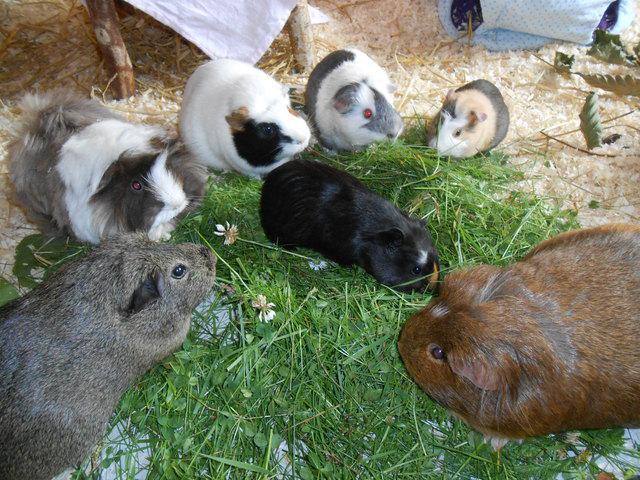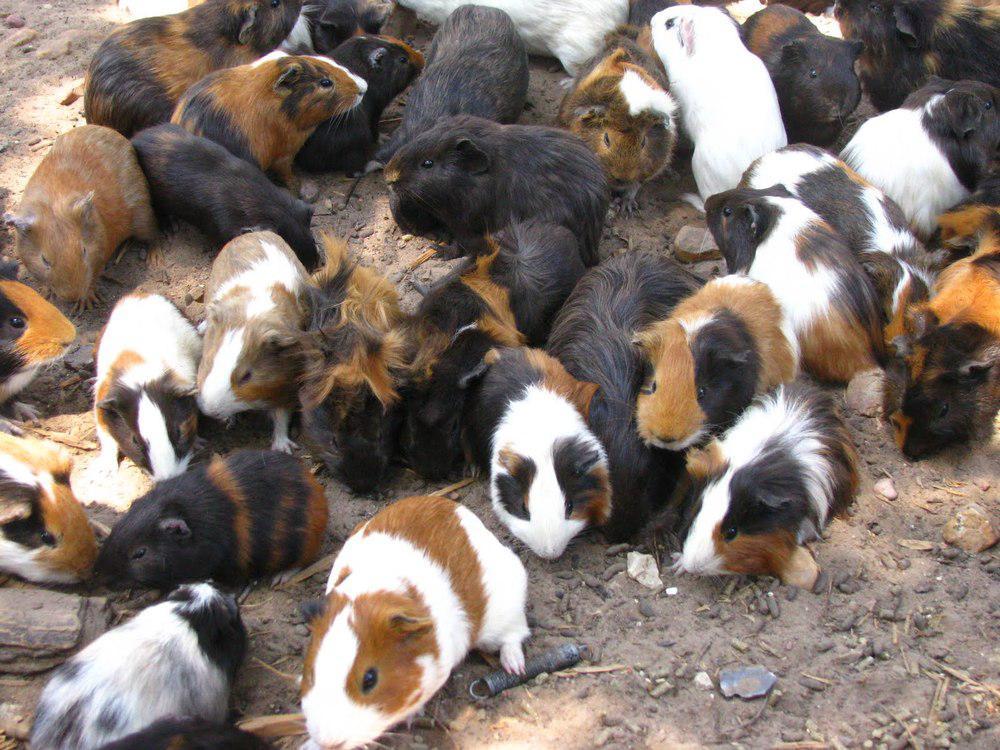The first image is the image on the left, the second image is the image on the right. Evaluate the accuracy of this statement regarding the images: "Some of the animals are sitting in a grassy area in one of the images.". Is it true? Answer yes or no. Yes. The first image is the image on the left, the second image is the image on the right. Considering the images on both sides, is "An image shows guinea pigs clustered around a pile of something that is brighter in color than the rest of the ground area." valid? Answer yes or no. Yes. 